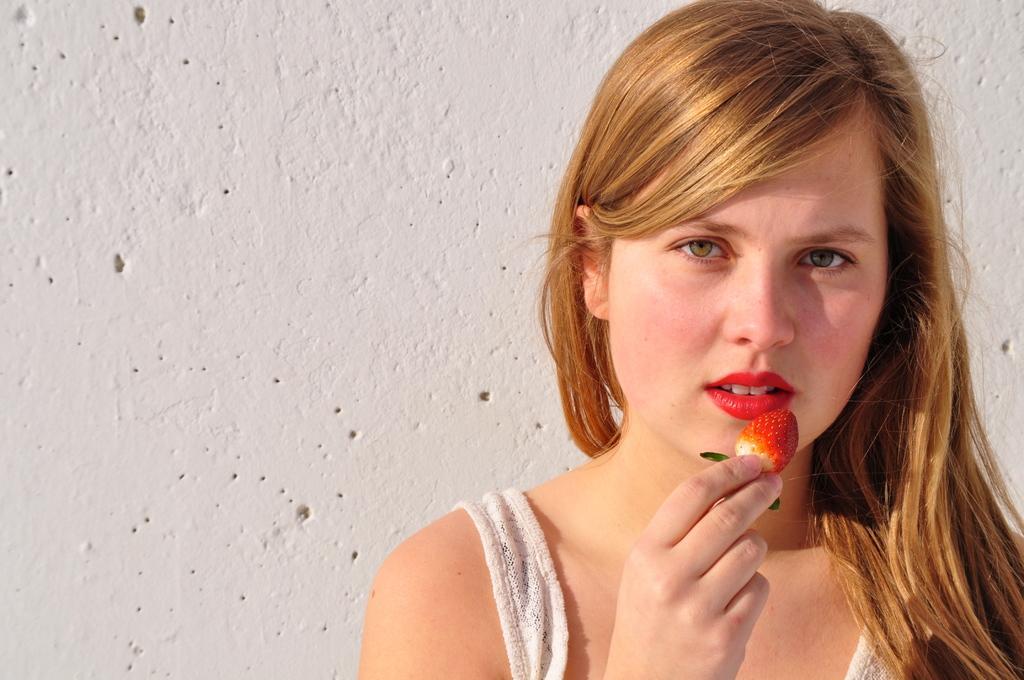In one or two sentences, can you explain what this image depicts? In this image, I can see the woman holding a strawberry in her hand. This is the wall, which is white in color. 